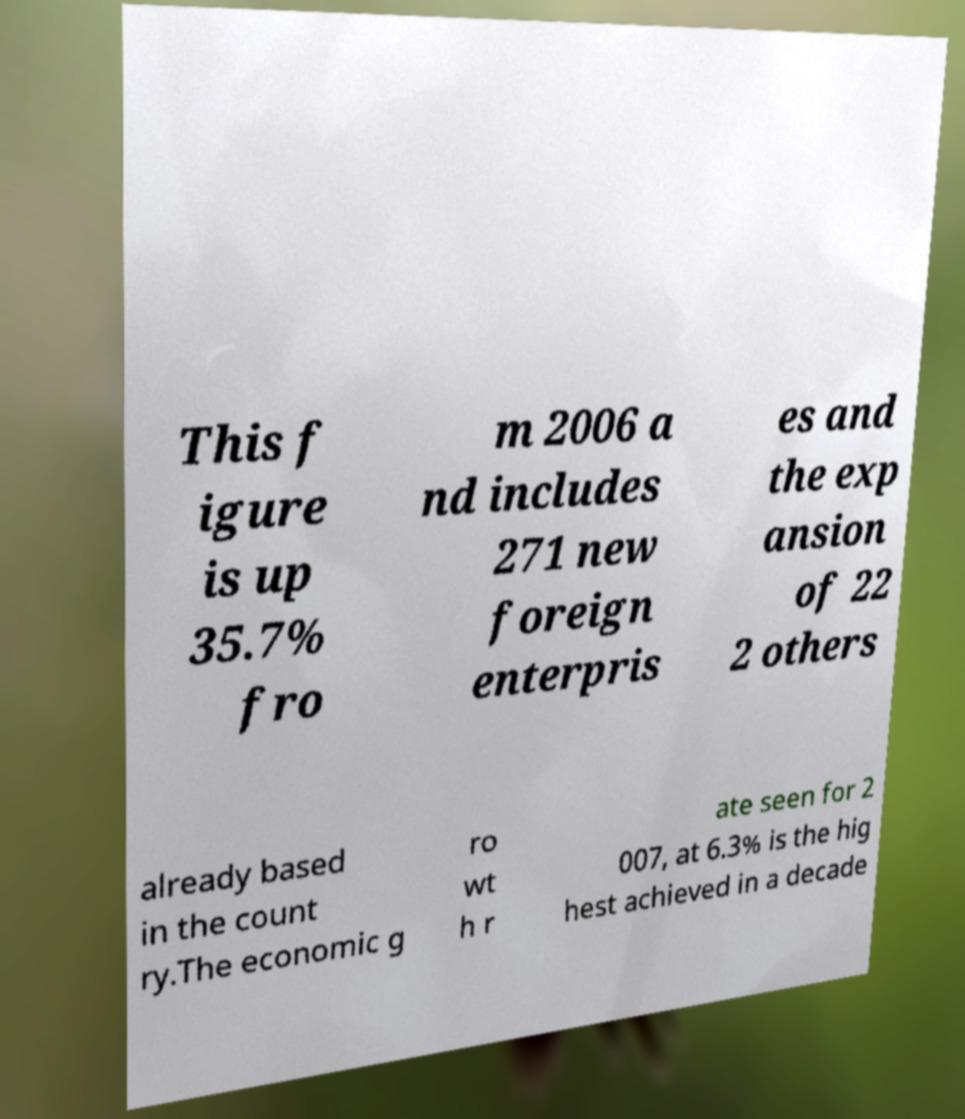Please identify and transcribe the text found in this image. This f igure is up 35.7% fro m 2006 a nd includes 271 new foreign enterpris es and the exp ansion of 22 2 others already based in the count ry.The economic g ro wt h r ate seen for 2 007, at 6.3% is the hig hest achieved in a decade 